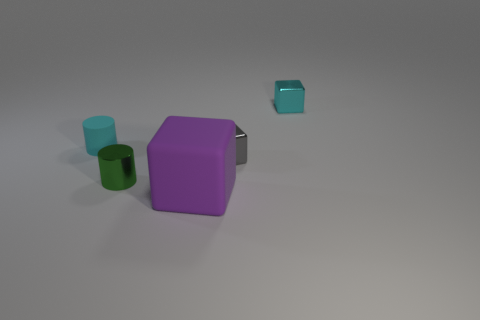Are there any other things that have the same size as the purple matte block?
Your response must be concise. No. There is a tiny rubber thing; is its color the same as the metal object to the right of the tiny gray metallic object?
Ensure brevity in your answer.  Yes. What size is the purple thing that is the same shape as the tiny cyan metal thing?
Make the answer very short. Large. The other small metal thing that is the same shape as the cyan shiny object is what color?
Provide a succinct answer. Gray. What number of cylinders are either small blue objects or cyan rubber things?
Keep it short and to the point. 1. Are there any rubber cubes right of the small block that is behind the cyan cylinder?
Keep it short and to the point. No. Is there anything else that is the same material as the tiny green thing?
Your answer should be compact. Yes. Is the shape of the large purple thing the same as the tiny gray metallic object left of the small cyan metal thing?
Make the answer very short. Yes. What number of other things are the same size as the gray shiny object?
Make the answer very short. 3. How many cyan things are metal objects or metal cubes?
Keep it short and to the point. 1. 